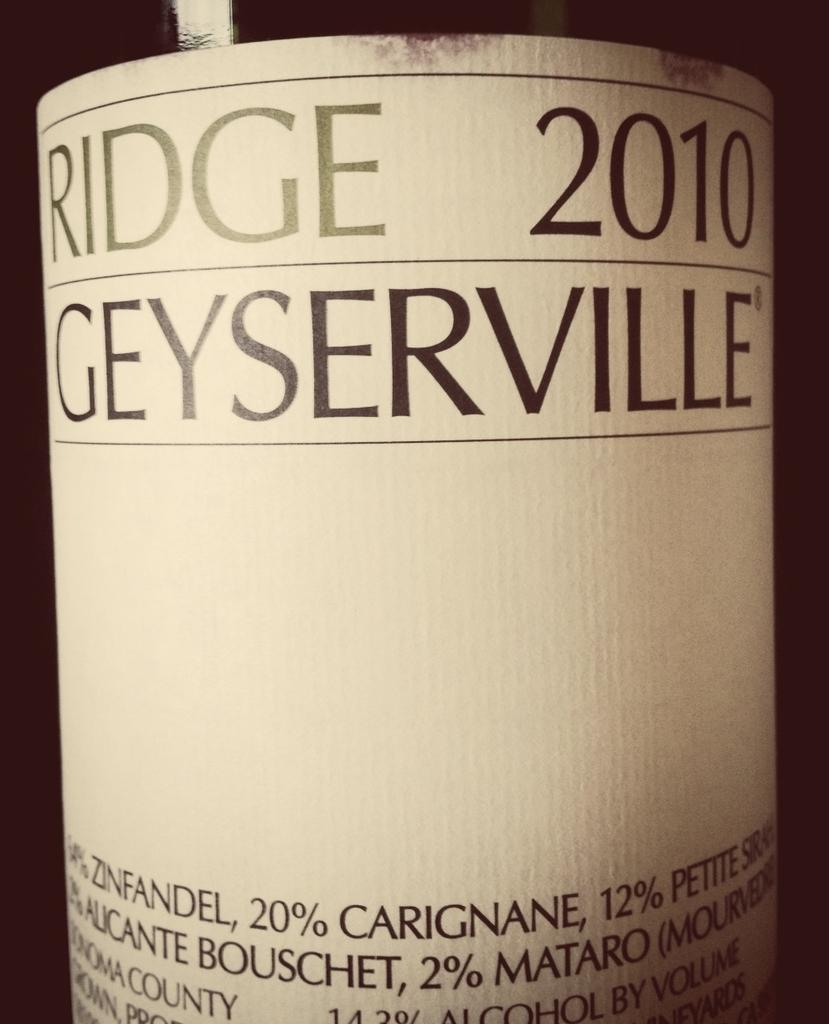<image>
Present a compact description of the photo's key features. Ridge 2010 Geyserville alcohol bottle that is in a picture 